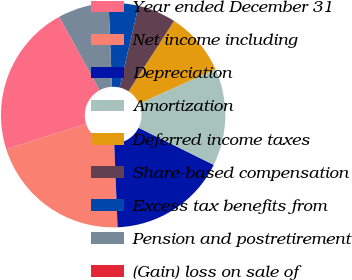Convert chart. <chart><loc_0><loc_0><loc_500><loc_500><pie_chart><fcel>Year ended December 31<fcel>Net income including<fcel>Depreciation<fcel>Amortization<fcel>Deferred income taxes<fcel>Share-based compensation<fcel>Excess tax benefits from<fcel>Pension and postretirement<fcel>(Gain) loss on sale of<nl><fcel>21.94%<fcel>20.72%<fcel>17.07%<fcel>14.02%<fcel>9.15%<fcel>5.5%<fcel>4.28%<fcel>7.32%<fcel>0.01%<nl></chart> 